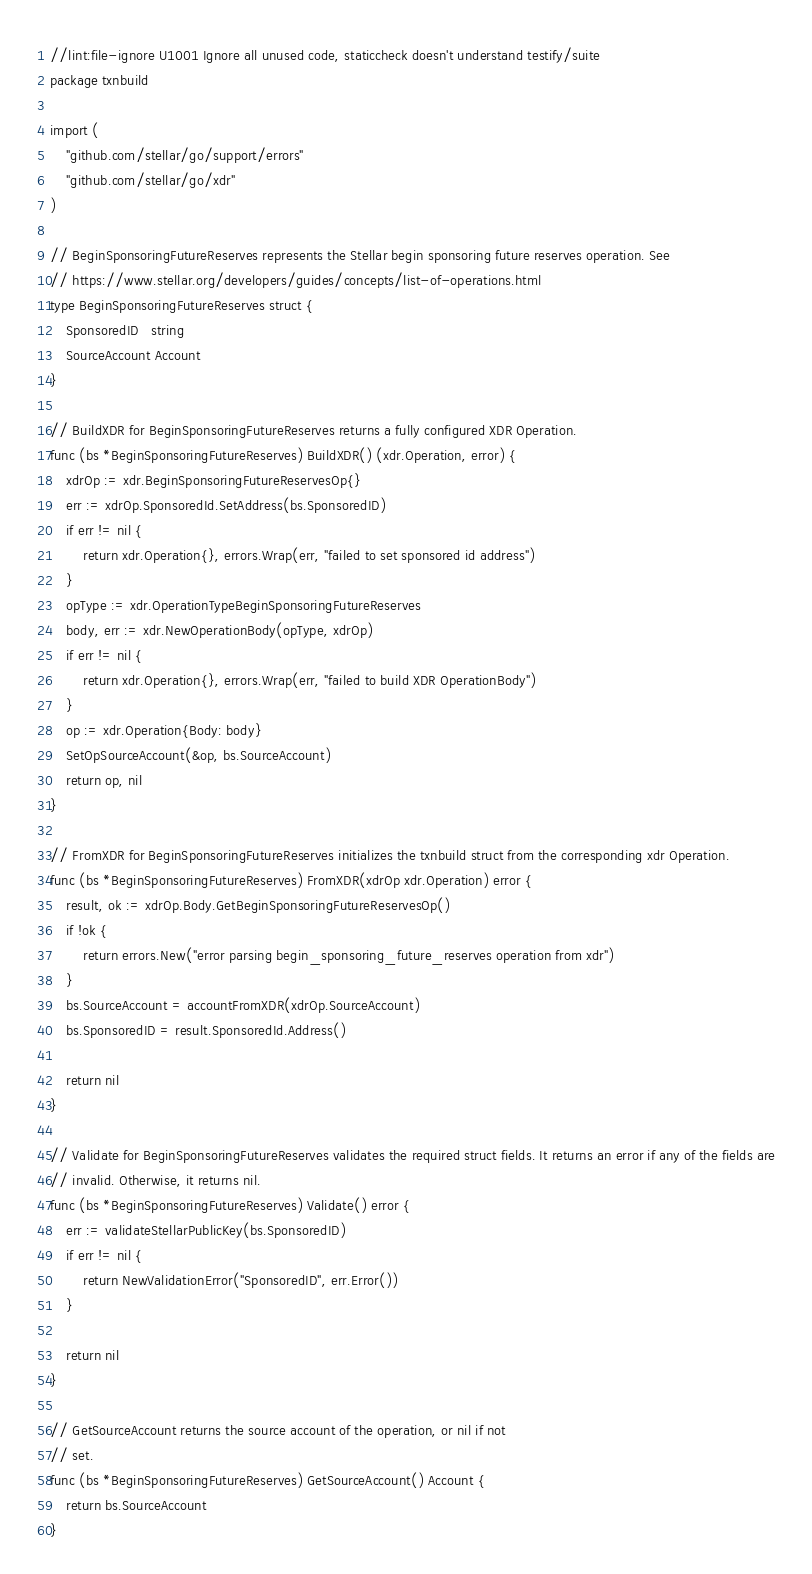<code> <loc_0><loc_0><loc_500><loc_500><_Go_>//lint:file-ignore U1001 Ignore all unused code, staticcheck doesn't understand testify/suite
package txnbuild

import (
	"github.com/stellar/go/support/errors"
	"github.com/stellar/go/xdr"
)

// BeginSponsoringFutureReserves represents the Stellar begin sponsoring future reserves operation. See
// https://www.stellar.org/developers/guides/concepts/list-of-operations.html
type BeginSponsoringFutureReserves struct {
	SponsoredID   string
	SourceAccount Account
}

// BuildXDR for BeginSponsoringFutureReserves returns a fully configured XDR Operation.
func (bs *BeginSponsoringFutureReserves) BuildXDR() (xdr.Operation, error) {
	xdrOp := xdr.BeginSponsoringFutureReservesOp{}
	err := xdrOp.SponsoredId.SetAddress(bs.SponsoredID)
	if err != nil {
		return xdr.Operation{}, errors.Wrap(err, "failed to set sponsored id address")
	}
	opType := xdr.OperationTypeBeginSponsoringFutureReserves
	body, err := xdr.NewOperationBody(opType, xdrOp)
	if err != nil {
		return xdr.Operation{}, errors.Wrap(err, "failed to build XDR OperationBody")
	}
	op := xdr.Operation{Body: body}
	SetOpSourceAccount(&op, bs.SourceAccount)
	return op, nil
}

// FromXDR for BeginSponsoringFutureReserves initializes the txnbuild struct from the corresponding xdr Operation.
func (bs *BeginSponsoringFutureReserves) FromXDR(xdrOp xdr.Operation) error {
	result, ok := xdrOp.Body.GetBeginSponsoringFutureReservesOp()
	if !ok {
		return errors.New("error parsing begin_sponsoring_future_reserves operation from xdr")
	}
	bs.SourceAccount = accountFromXDR(xdrOp.SourceAccount)
	bs.SponsoredID = result.SponsoredId.Address()

	return nil
}

// Validate for BeginSponsoringFutureReserves validates the required struct fields. It returns an error if any of the fields are
// invalid. Otherwise, it returns nil.
func (bs *BeginSponsoringFutureReserves) Validate() error {
	err := validateStellarPublicKey(bs.SponsoredID)
	if err != nil {
		return NewValidationError("SponsoredID", err.Error())
	}

	return nil
}

// GetSourceAccount returns the source account of the operation, or nil if not
// set.
func (bs *BeginSponsoringFutureReserves) GetSourceAccount() Account {
	return bs.SourceAccount
}
</code> 